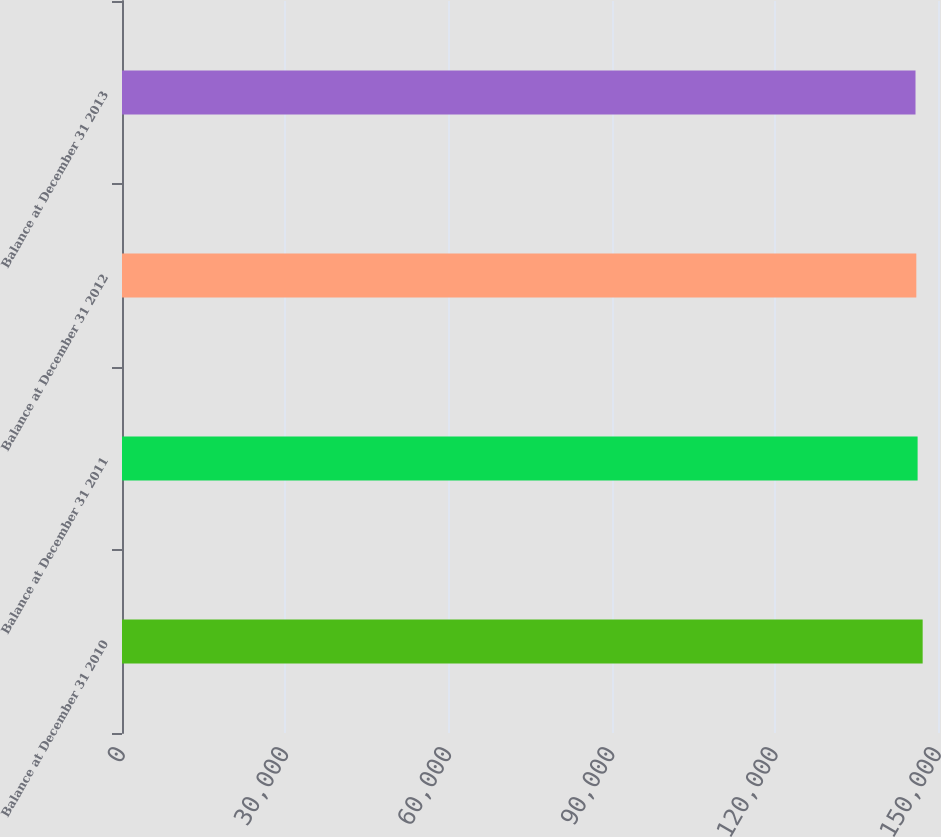Convert chart. <chart><loc_0><loc_0><loc_500><loc_500><bar_chart><fcel>Balance at December 31 2010<fcel>Balance at December 31 2011<fcel>Balance at December 31 2012<fcel>Balance at December 31 2013<nl><fcel>147181<fcel>146251<fcel>146015<fcel>145864<nl></chart> 